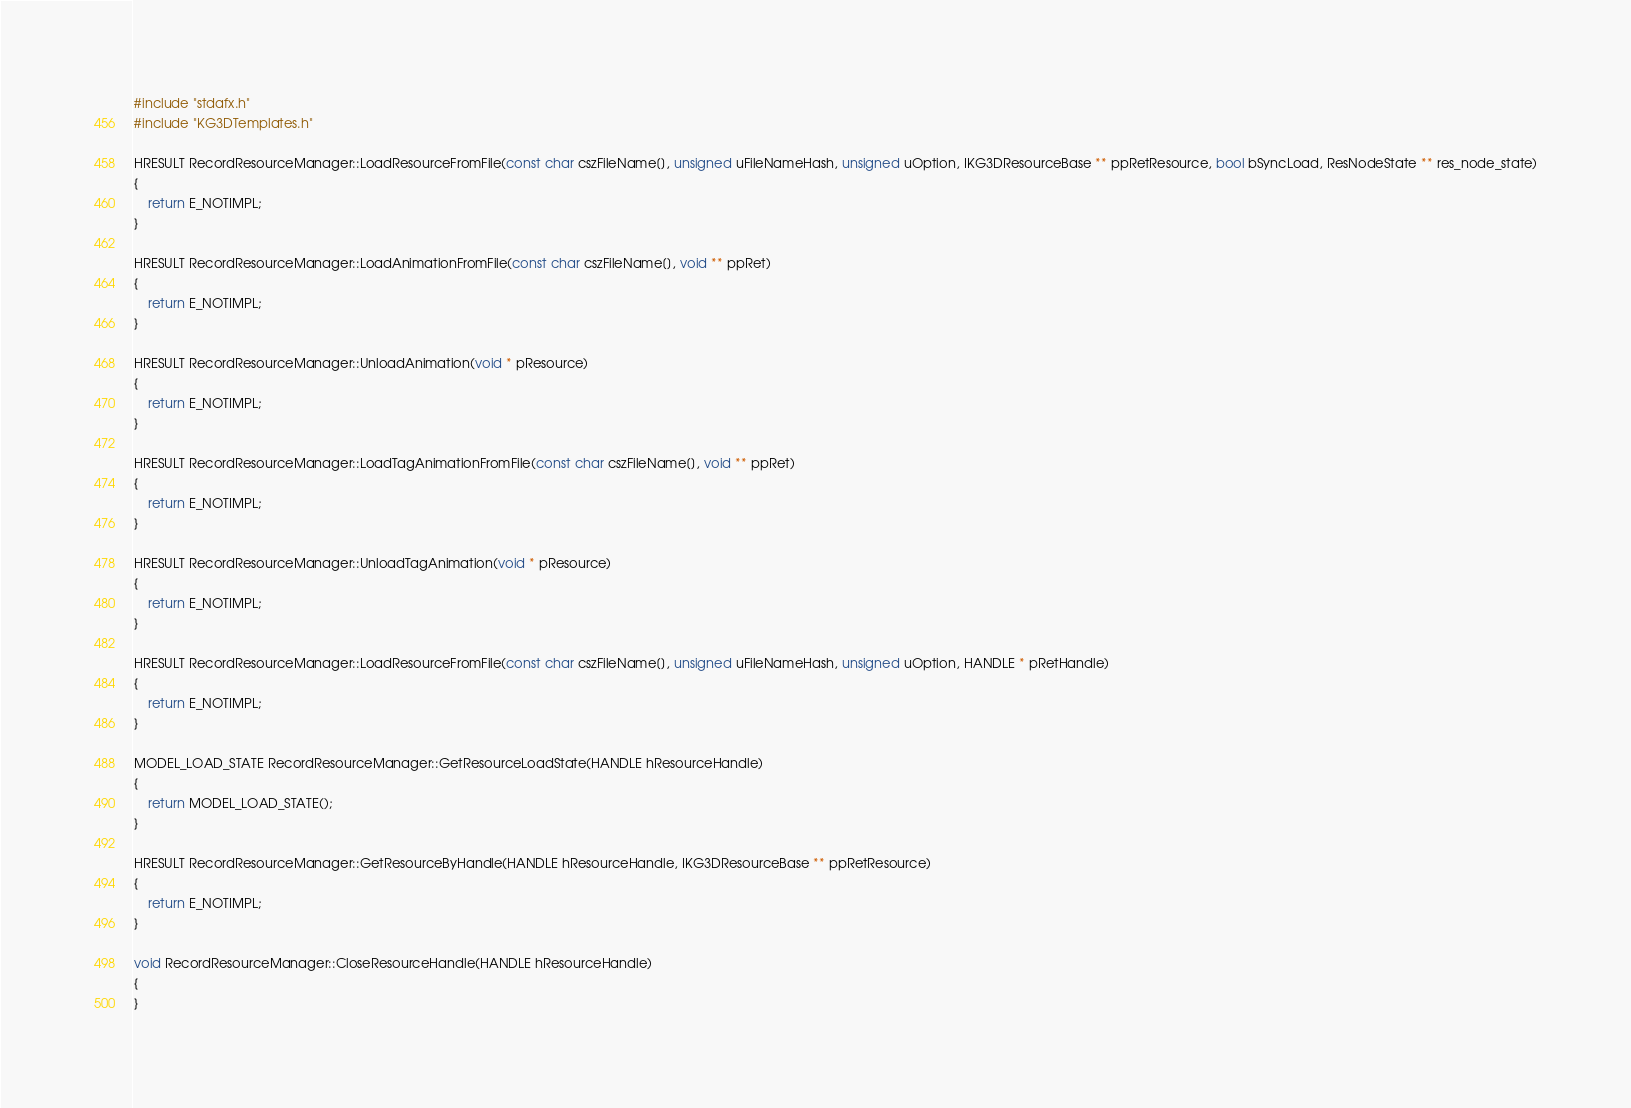<code> <loc_0><loc_0><loc_500><loc_500><_C++_>#include "stdafx.h"
#include "KG3DTemplates.h"

HRESULT RecordResourceManager::LoadResourceFromFile(const char cszFileName[], unsigned uFileNameHash, unsigned uOption, IKG3DResourceBase ** ppRetResource, bool bSyncLoad, ResNodeState ** res_node_state)
{
	return E_NOTIMPL;
}

HRESULT RecordResourceManager::LoadAnimationFromFile(const char cszFileName[], void ** ppRet)
{
	return E_NOTIMPL;
}

HRESULT RecordResourceManager::UnloadAnimation(void * pResource)
{
	return E_NOTIMPL;
}

HRESULT RecordResourceManager::LoadTagAnimationFromFile(const char cszFileName[], void ** ppRet)
{
	return E_NOTIMPL;
}

HRESULT RecordResourceManager::UnloadTagAnimation(void * pResource)
{
	return E_NOTIMPL;
}

HRESULT RecordResourceManager::LoadResourceFromFile(const char cszFileName[], unsigned uFileNameHash, unsigned uOption, HANDLE * pRetHandle)
{
	return E_NOTIMPL;
}

MODEL_LOAD_STATE RecordResourceManager::GetResourceLoadState(HANDLE hResourceHandle)
{
	return MODEL_LOAD_STATE();
}

HRESULT RecordResourceManager::GetResourceByHandle(HANDLE hResourceHandle, IKG3DResourceBase ** ppRetResource)
{
	return E_NOTIMPL;
}

void RecordResourceManager::CloseResourceHandle(HANDLE hResourceHandle)
{
}
</code> 